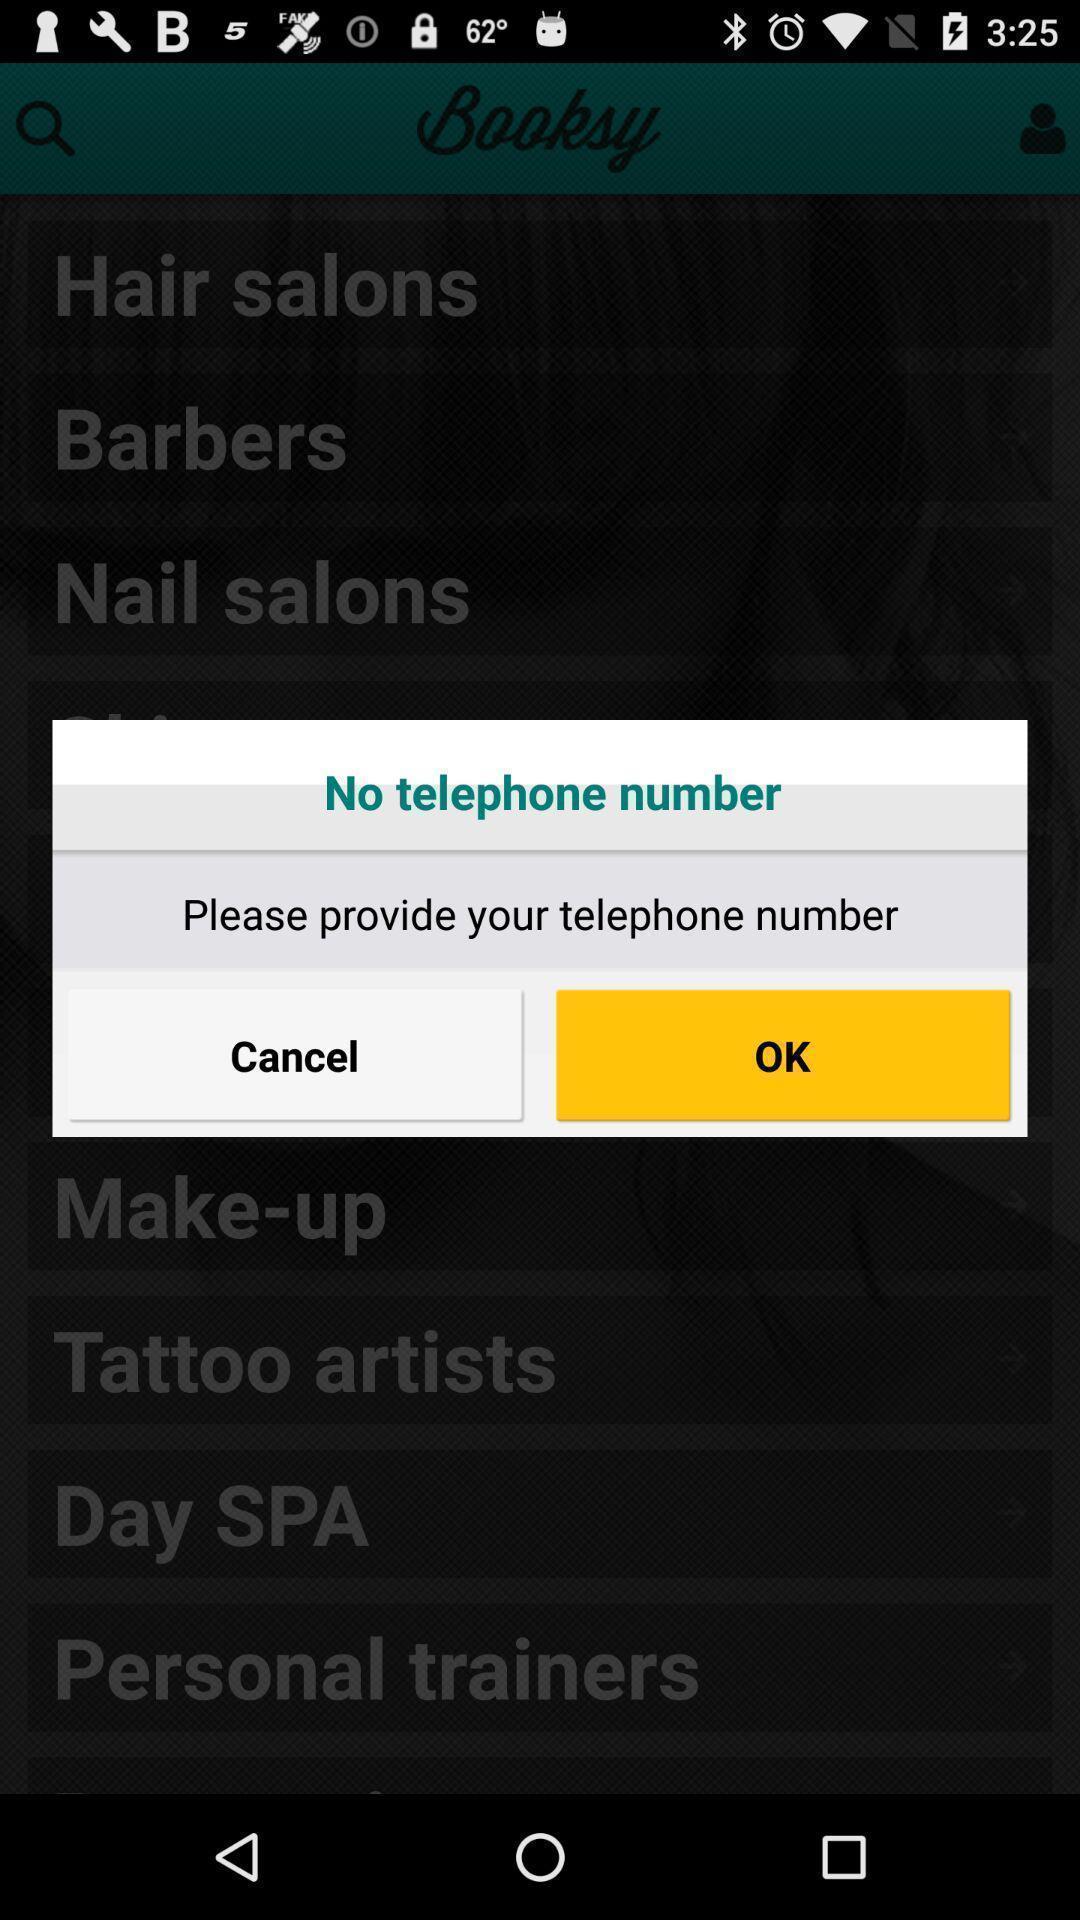Summarize the main components in this picture. Popup displaying information about beauty and wellness application. 